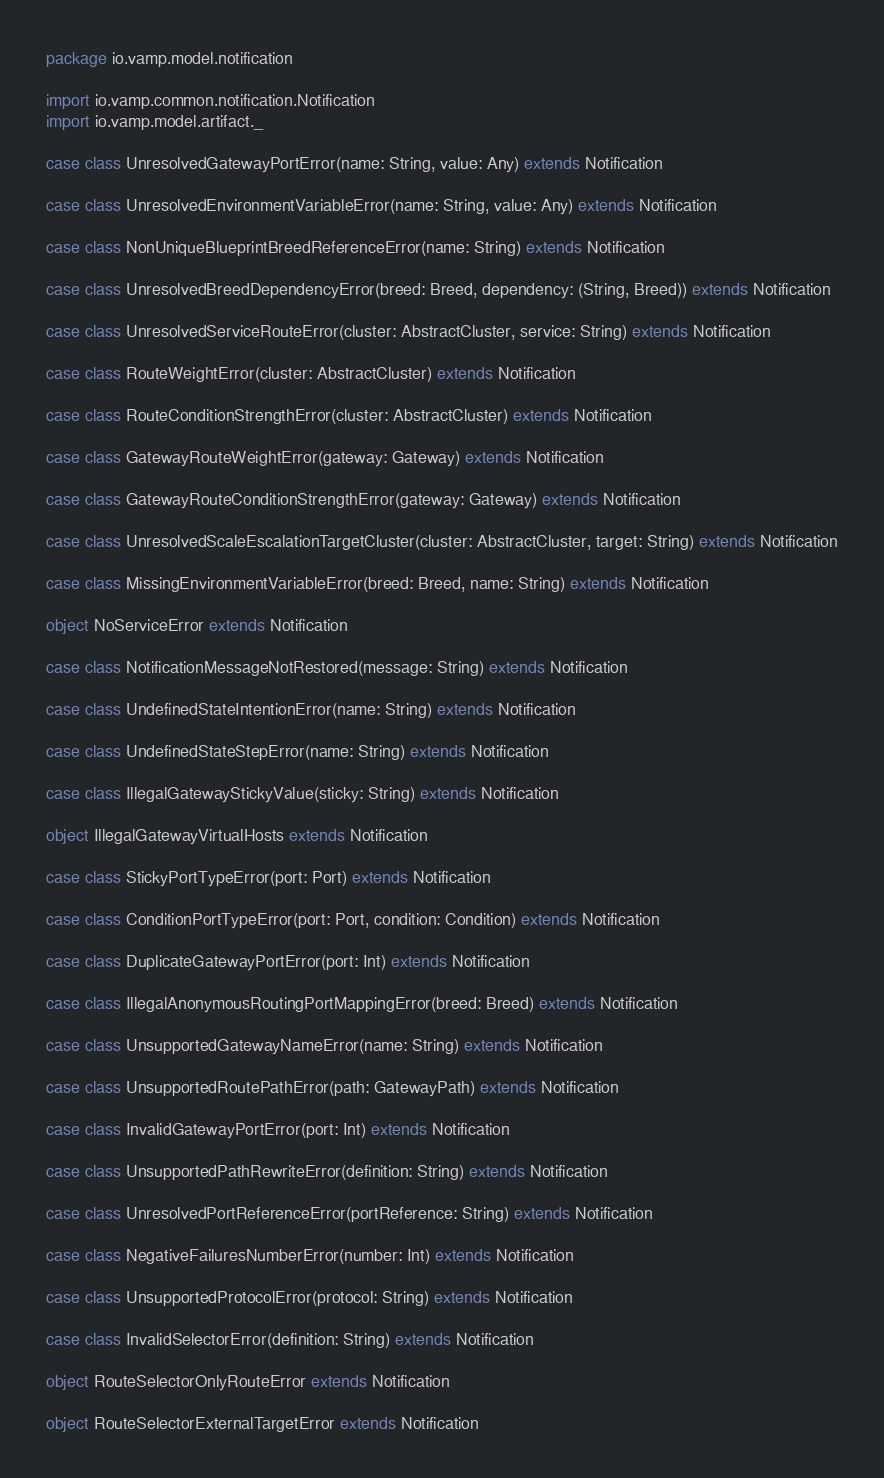<code> <loc_0><loc_0><loc_500><loc_500><_Scala_>package io.vamp.model.notification

import io.vamp.common.notification.Notification
import io.vamp.model.artifact._

case class UnresolvedGatewayPortError(name: String, value: Any) extends Notification

case class UnresolvedEnvironmentVariableError(name: String, value: Any) extends Notification

case class NonUniqueBlueprintBreedReferenceError(name: String) extends Notification

case class UnresolvedBreedDependencyError(breed: Breed, dependency: (String, Breed)) extends Notification

case class UnresolvedServiceRouteError(cluster: AbstractCluster, service: String) extends Notification

case class RouteWeightError(cluster: AbstractCluster) extends Notification

case class RouteConditionStrengthError(cluster: AbstractCluster) extends Notification

case class GatewayRouteWeightError(gateway: Gateway) extends Notification

case class GatewayRouteConditionStrengthError(gateway: Gateway) extends Notification

case class UnresolvedScaleEscalationTargetCluster(cluster: AbstractCluster, target: String) extends Notification

case class MissingEnvironmentVariableError(breed: Breed, name: String) extends Notification

object NoServiceError extends Notification

case class NotificationMessageNotRestored(message: String) extends Notification

case class UndefinedStateIntentionError(name: String) extends Notification

case class UndefinedStateStepError(name: String) extends Notification

case class IllegalGatewayStickyValue(sticky: String) extends Notification

object IllegalGatewayVirtualHosts extends Notification

case class StickyPortTypeError(port: Port) extends Notification

case class ConditionPortTypeError(port: Port, condition: Condition) extends Notification

case class DuplicateGatewayPortError(port: Int) extends Notification

case class IllegalAnonymousRoutingPortMappingError(breed: Breed) extends Notification

case class UnsupportedGatewayNameError(name: String) extends Notification

case class UnsupportedRoutePathError(path: GatewayPath) extends Notification

case class InvalidGatewayPortError(port: Int) extends Notification

case class UnsupportedPathRewriteError(definition: String) extends Notification

case class UnresolvedPortReferenceError(portReference: String) extends Notification

case class NegativeFailuresNumberError(number: Int) extends Notification

case class UnsupportedProtocolError(protocol: String) extends Notification

case class InvalidSelectorError(definition: String) extends Notification

object RouteSelectorOnlyRouteError extends Notification

object RouteSelectorExternalTargetError extends Notification
</code> 